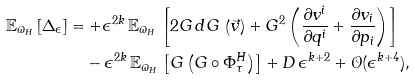Convert formula to latex. <formula><loc_0><loc_0><loc_500><loc_500>\mathbb { E } _ { \varpi _ { H } } \left [ \Delta _ { \epsilon } \right ] & = + \epsilon ^ { 2 k } \, \mathbb { E } _ { \varpi _ { H } } \, \left [ 2 G \, d G \, \left ( \vec { v } \right ) + G ^ { 2 } \left ( \frac { \partial v ^ { i } } { \partial q ^ { i } } + \frac { \partial v _ { i } } { \partial p _ { i } } \right ) \right ] \\ & \quad - \epsilon ^ { 2 k } \, \mathbb { E } _ { \varpi _ { H } } \, \left [ G \left ( G \circ \Phi ^ { H } _ { \tau } \right ) \right ] + D \, \epsilon ^ { k + 2 } + \mathcal { O } ( \epsilon ^ { k + 4 } ) ,</formula> 